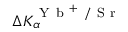Convert formula to latex. <formula><loc_0><loc_0><loc_500><loc_500>\Delta K _ { \alpha } ^ { Y b ^ { + } / S r }</formula> 